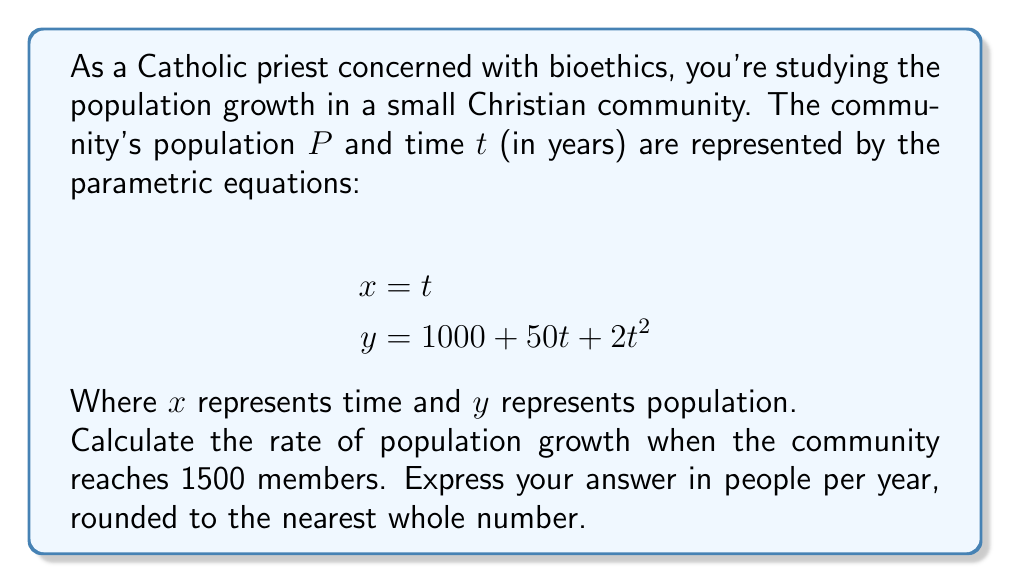Teach me how to tackle this problem. Let's approach this step-by-step:

1) First, we need to find the time $t$ when the population reaches 1500. We can do this by solving the equation:

   $$1500 = 1000 + 50t + 2t^2$$

2) Rearranging the equation:

   $$2t^2 + 50t - 500 = 0$$

3) This is a quadratic equation. We can solve it using the quadratic formula:

   $$t = \frac{-b \pm \sqrt{b^2 - 4ac}}{2a}$$

   Where $a=2$, $b=50$, and $c=-500$

4) Plugging in these values:

   $$t = \frac{-50 \pm \sqrt{50^2 - 4(2)(-500)}}{2(2)}$$
   $$= \frac{-50 \pm \sqrt{2500 + 4000}}{4}$$
   $$= \frac{-50 \pm \sqrt{6500}}{4}$$
   $$= \frac{-50 \pm 80.62}{4}$$

5) This gives us two solutions: $t \approx 7.66$ or $t \approx -14.66$. Since time can't be negative in this context, we take $t \approx 7.66$ years.

6) Now, to find the rate of population growth, we need to find $\frac{dy}{dt}$ when $t = 7.66$.

7) From the parametric equations, we can derive:

   $$\frac{dy}{dt} = 50 + 4t$$

8) Plugging in $t = 7.66$:

   $$\frac{dy}{dt} = 50 + 4(7.66) = 50 + 30.64 = 80.64$$

9) Rounding to the nearest whole number, we get 81 people per year.
Answer: 81 people per year 